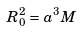<formula> <loc_0><loc_0><loc_500><loc_500>R _ { 0 } ^ { 2 } = a ^ { 3 } M</formula> 